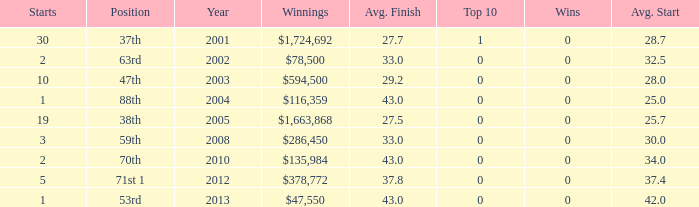How many starts for an average finish greater than 43? None. 